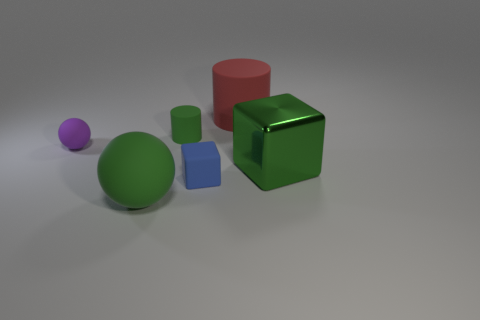What color is the big cylinder that is made of the same material as the tiny cube?
Provide a short and direct response. Red. How many gray things are either big metal objects or big cylinders?
Offer a terse response. 0. Is the number of small purple matte things greater than the number of big red metallic blocks?
Keep it short and to the point. Yes. How many things are either large green things on the right side of the tiny blue rubber thing or cylinders that are on the left side of the blue matte object?
Keep it short and to the point. 2. The sphere that is the same size as the red rubber cylinder is what color?
Offer a very short reply. Green. Is the material of the small ball the same as the tiny block?
Offer a terse response. Yes. The red thing that is to the right of the tiny object on the left side of the big sphere is made of what material?
Provide a succinct answer. Rubber. Are there more large green balls that are in front of the green matte ball than cyan rubber cylinders?
Make the answer very short. No. What number of other things are the same size as the blue rubber block?
Offer a terse response. 2. Is the tiny block the same color as the large cube?
Your answer should be compact. No. 